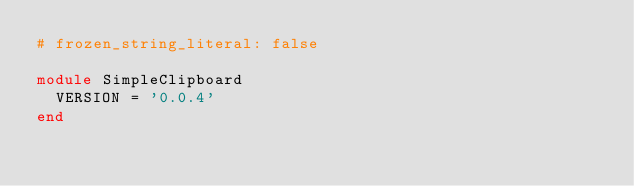<code> <loc_0><loc_0><loc_500><loc_500><_Ruby_># frozen_string_literal: false

module SimpleClipboard
  VERSION = '0.0.4'
end
</code> 